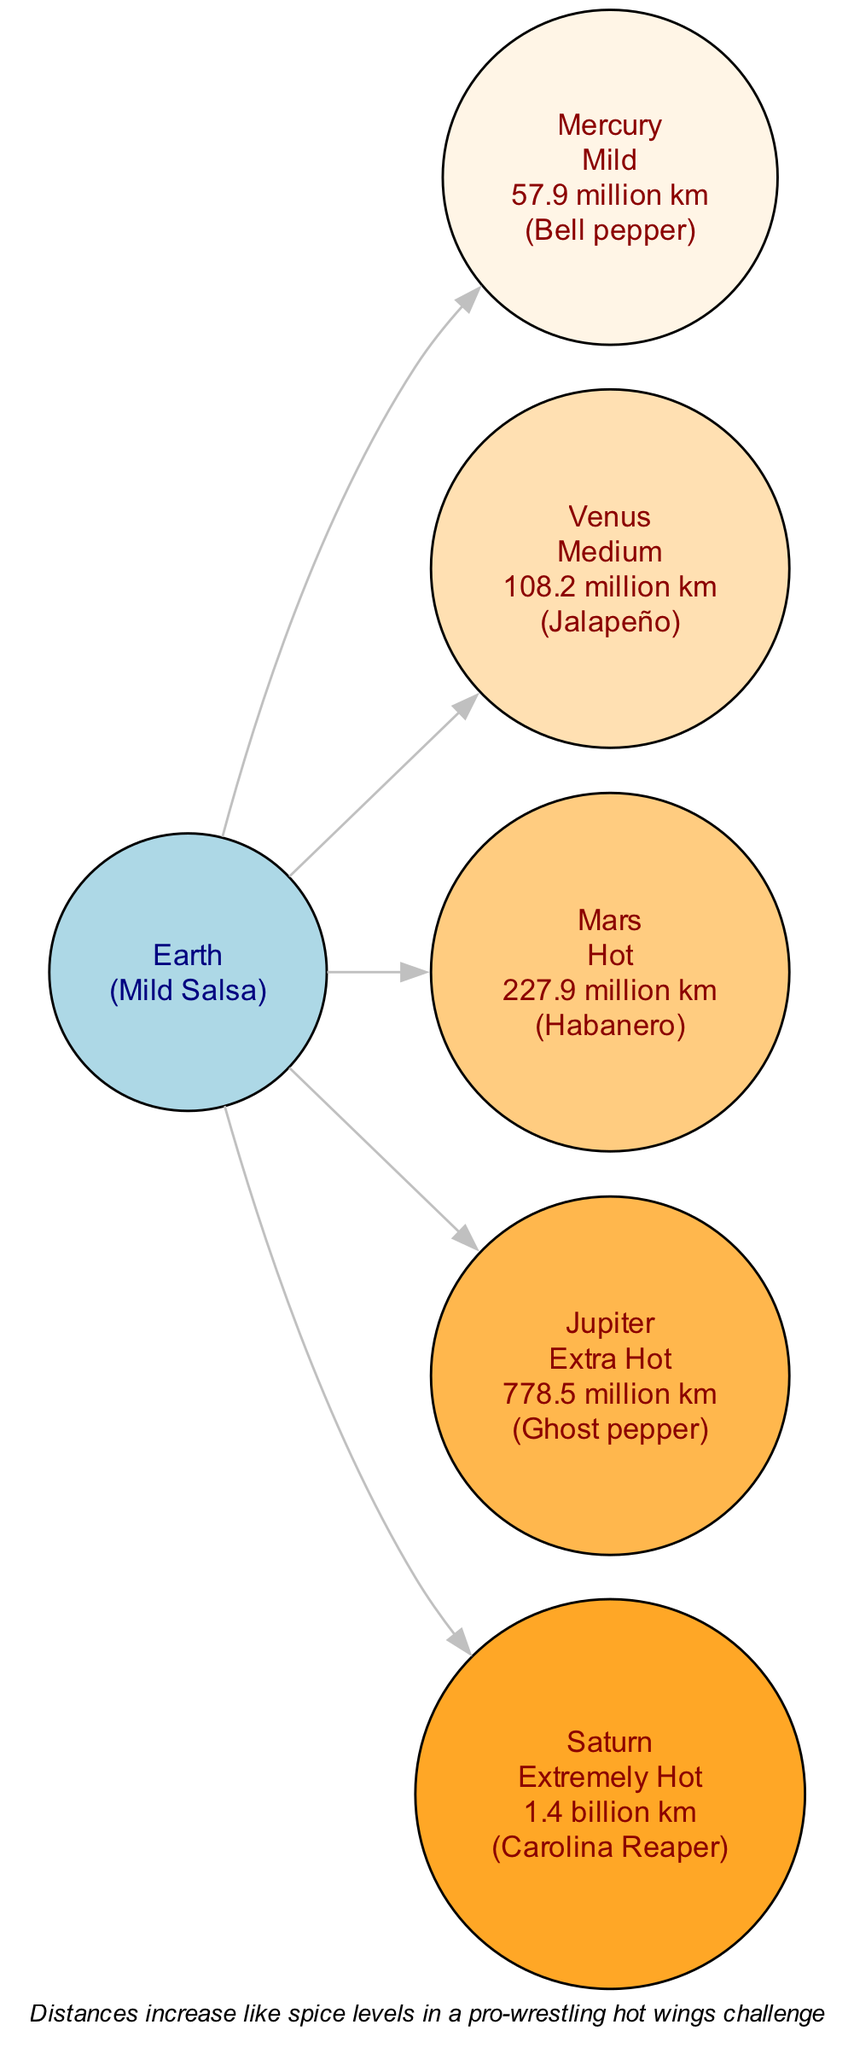What is the spice level for Mars? The diagram indicates that Mars is classified as "Hot." This information is directly associated with the corresponding node for Mars which details its distance and spice ranking.
Answer: Hot How far is Jupiter from Earth? According to the diagram, the distance listed for Jupiter is "778.5 million km." This value is displayed within the node connected to Earth.
Answer: 778.5 million km Which planet is associated with the Carolina Reaper? The node for Saturn in the diagram specifies that it is associated with the "Carolina Reaper," which is described as "Extremely Hot." This means Saturn is visually represented with this spice level.
Answer: Saturn How many planets are depicted in the diagram? By reviewing the diagram, we identify five planets connected to Earth, each representing different spice levels based on their distances. Thus, counting each planet gives us a total of five.
Answer: 5 What relation does the spice level of Mercury have to its distance from Earth? The diagram shows that Mercury is labeled as "Mild" and is at a distance of "57.9 million km." This reveals that Mercury is the closest planet in this diagram, paralleling its milder spice level on the scale.
Answer: Mild Which planet experiences the highest spice level? The diagram indicates that Saturn has the highest spice classification, labeled as "Extremely Hot" and corresponds to the farthest distance shown, which is "1.4 billion km." This association establishes Saturn as having the highest spice intensity.
Answer: Saturn What does the note in the diagram state? The note at the bottom of the diagram explains that "Distances increase like spice levels in a pro-wrestling hot wings challenge." This analogy helps to understand the scaling concept used in the diagram.
Answer: Distances increase like spice levels in a pro-wrestling hot wings challenge Which planet is closest to Earth? The diagram shows that Mercury has the shortest distance of "57.9 million km" from Earth, making it the closest planet based on the given distances.
Answer: Mercury 